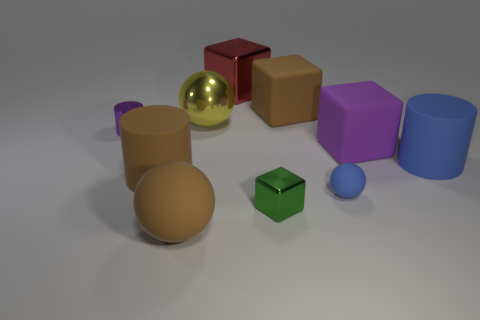Subtract all big spheres. How many spheres are left? 1 Subtract 1 cubes. How many cubes are left? 3 Subtract all purple cubes. How many cubes are left? 3 Subtract all cyan cubes. Subtract all yellow cylinders. How many cubes are left? 4 Subtract all cylinders. How many objects are left? 7 Subtract 0 red spheres. How many objects are left? 10 Subtract all red metal cubes. Subtract all small cylinders. How many objects are left? 8 Add 6 big spheres. How many big spheres are left? 8 Add 1 blue things. How many blue things exist? 3 